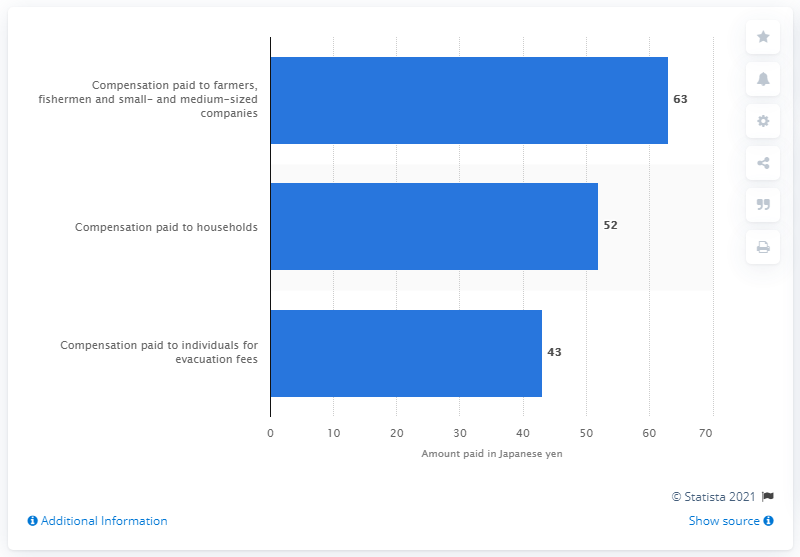List a handful of essential elements in this visual. The affected households received a total of 52 Japanese yen from TEPCO as compensation. 